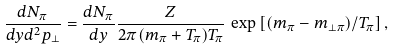<formula> <loc_0><loc_0><loc_500><loc_500>\frac { d N _ { \pi } } { d y d ^ { 2 } p _ { \perp } } = \frac { d N _ { \pi } } { d y } \frac { Z } { 2 \pi ( m _ { \pi } + T _ { \pi } ) T _ { \pi } } \, \exp \left [ ( m _ { \pi } - m _ { \perp \pi } ) / T _ { \pi } \right ] ,</formula> 